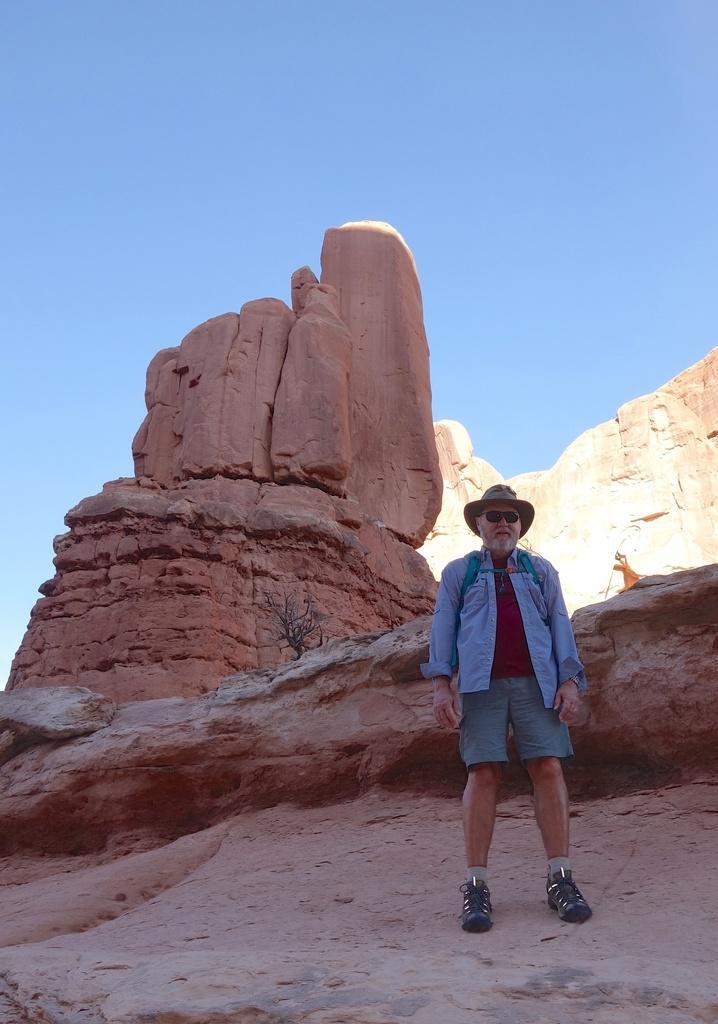Can you describe this image briefly? In this image I can see a man is standing. The man is wearing a hat, shades, shorts and footwear. In the background I can see mountain and the sky. 